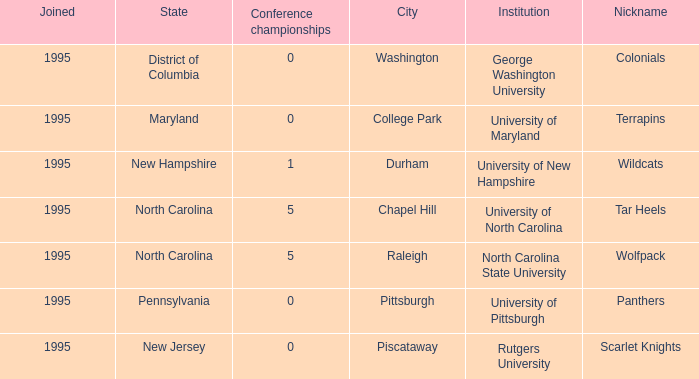What is the lowest year joined in the city of College Park at the Conference championships smaller than 0? None. 